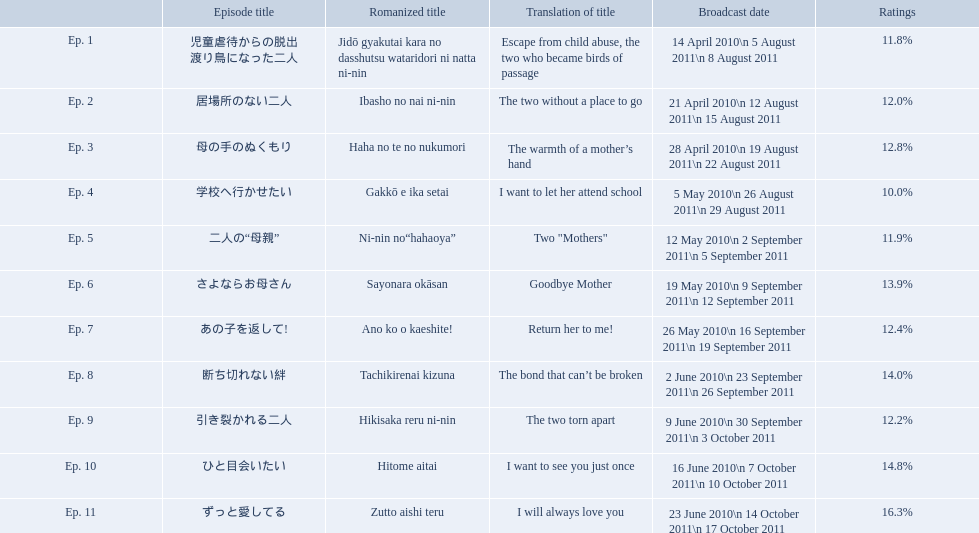Parse the table in full. {'header': ['', 'Episode title', 'Romanized title', 'Translation of title', 'Broadcast date', 'Ratings'], 'rows': [['Ep. 1', '児童虐待からの脱出 渡り鳥になった二人', 'Jidō gyakutai kara no dasshutsu wataridori ni natta ni-nin', 'Escape from child abuse, the two who became birds of passage', '14 April 2010\\n 5 August 2011\\n 8 August 2011', '11.8%'], ['Ep. 2', '居場所のない二人', 'Ibasho no nai ni-nin', 'The two without a place to go', '21 April 2010\\n 12 August 2011\\n 15 August 2011', '12.0%'], ['Ep. 3', '母の手のぬくもり', 'Haha no te no nukumori', 'The warmth of a mother’s hand', '28 April 2010\\n 19 August 2011\\n 22 August 2011', '12.8%'], ['Ep. 4', '学校へ行かせたい', 'Gakkō e ika setai', 'I want to let her attend school', '5 May 2010\\n 26 August 2011\\n 29 August 2011', '10.0%'], ['Ep. 5', '二人の“母親”', 'Ni-nin no“hahaoya”', 'Two "Mothers"', '12 May 2010\\n 2 September 2011\\n 5 September 2011', '11.9%'], ['Ep. 6', 'さよならお母さん', 'Sayonara okāsan', 'Goodbye Mother', '19 May 2010\\n 9 September 2011\\n 12 September 2011', '13.9%'], ['Ep. 7', 'あの子を返して!', 'Ano ko o kaeshite!', 'Return her to me!', '26 May 2010\\n 16 September 2011\\n 19 September 2011', '12.4%'], ['Ep. 8', '断ち切れない絆', 'Tachikirenai kizuna', 'The bond that can’t be broken', '2 June 2010\\n 23 September 2011\\n 26 September 2011', '14.0%'], ['Ep. 9', '引き裂かれる二人', 'Hikisaka reru ni-nin', 'The two torn apart', '9 June 2010\\n 30 September 2011\\n 3 October 2011', '12.2%'], ['Ep. 10', 'ひと目会いたい', 'Hitome aitai', 'I want to see you just once', '16 June 2010\\n 7 October 2011\\n 10 October 2011', '14.8%'], ['Ep. 11', 'ずっと愛してる', 'Zutto aishi teru', 'I will always love you', '23 June 2010\\n 14 October 2011\\n 17 October 2011', '16.3%']]} What are all the episodes? Ep. 1, Ep. 2, Ep. 3, Ep. 4, Ep. 5, Ep. 6, Ep. 7, Ep. 8, Ep. 9, Ep. 10, Ep. 11. Of these, which ones have a rating of 14%? Ep. 8, Ep. 10. Of these, which one is not ep. 10? Ep. 8. What are the episode numbers? Ep. 1, Ep. 2, Ep. 3, Ep. 4, Ep. 5, Ep. 6, Ep. 7, Ep. 8, Ep. 9, Ep. 10, Ep. 11. What was the percentage of total ratings for episode 8? 14.0%. Which episode was titled the two without a place to go? Ep. 2. What was the title of ep. 3? The warmth of a mother’s hand. Which episode had a rating of 10.0%? Ep. 4. What are all the titles the episodes of the mother tv series? 児童虐待からの脱出 渡り鳥になった二人, 居場所のない二人, 母の手のぬくもり, 学校へ行かせたい, 二人の“母親”, さよならお母さん, あの子を返して!, 断ち切れない絆, 引き裂かれる二人, ひと目会いたい, ずっと愛してる. What are all of the ratings for each of the shows? 11.8%, 12.0%, 12.8%, 10.0%, 11.9%, 13.9%, 12.4%, 14.0%, 12.2%, 14.8%, 16.3%. What is the highest score for ratings? 16.3%. What episode corresponds to that rating? ずっと愛してる. What is the overall number of episodes? Ep. 1, Ep. 2, Ep. 3, Ep. 4, Ep. 5, Ep. 6, Ep. 7, Ep. 8, Ep. 9, Ep. 10, Ep. 11. Among them, which one carries the title "the bond that can't be broken"? Ep. 8. What percentage of ratings did that particular episode receive? 14.0%. What is the title of episode 8? 断ち切れない絆. What were the ratings for this episode? 14.0%. What are the complete list of episode titles in the mother tv series? 児童虐待からの脱出 渡り鳥になった二人, 居場所のない二人, 母の手のぬくもり, 学校へ行かせたい, 二人の“母親”, さよならお母さん, あの子を返して!, 断ち切れない絆, 引き裂かれる二人, ひと目会いたい, ずっと愛してる. What are the respective ratings for each episode? 11.8%, 12.0%, 12.8%, 10.0%, 11.9%, 13.9%, 12.4%, 14.0%, 12.2%, 14.8%, 16.3%. What is the top rating received? 16.3%. Which episode corresponds to that score? ずっと愛してる. What are the installment numbers? Ep. 1, Ep. 2, Ep. 3, Ep. 4, Ep. 5, Ep. 6, Ep. 7, Ep. 8, Ep. 9, Ep. 10, Ep. 11. What was the proportion of total ratings for episode 8? 14.0%. What are the titles of all the episodes in the mother television series? 児童虐待からの脱出 渡り鳥になった二人, 居場所のない二人, 母の手のぬくもり, 学校へ行かせたい, 二人の“母親”, さよならお母さん, あの子を返して!, 断ち切れない絆, 引き裂かれる二人, ひと目会いたい, ずっと愛してる. What are the ratings given to each of the episodes? 11.8%, 12.0%, 12.8%, 10.0%, 11.9%, 13.9%, 12.4%, 14.0%, 12.2%, 14.8%, 16.3%. What is the peak rating achieved? 16.3%. What episode is linked to that rating? ずっと愛してる. What are the names of every episode in the mother television series? 児童虐待からの脱出 渡り鳥になった二人, 居場所のない二人, 母の手のぬくもり, 学校へ行かせたい, 二人の“母親”, さよならお母さん, あの子を返して!, 断ち切れない絆, 引き裂かれる二人, ひと目会いたい, ずっと愛してる. What are the individual ratings for each episode? 11.8%, 12.0%, 12.8%, 10.0%, 11.9%, 13.9%, 12.4%, 14.0%, 12.2%, 14.8%, 16.3%. What is the maximum rating achieved? 16.3%. Which episode is associated with that rating? ずっと愛してる. What episodes are included in the series "mother"? 児童虐待からの脱出 渡り鳥になった二人, 居場所のない二人, 母の手のぬくもり, 学校へ行かせたい, 二人の“母親”, さよならお母さん, あの子を返して!, 断ち切れない絆, 引き裂かれる二人, ひと目会いたい, ずっと愛してる. What is the rating for the 10th episode? 14.8%. Additionally, what other ratings fall within the 14-15 range? Ep. 8. Can you provide the episodes of "mother"? 児童虐待からの脱出 渡り鳥になった二人, 居場所のない二人, 母の手のぬくもり, 学校へ行かせたい, 二人の“母親”, さよならお母さん, あの子を返して!, 断ち切れない絆, 引き裂かれる二人, ひと目会いたい, ずっと愛してる. What rating does the 10th episode have? 14.8%. Also, which other ratings are in the 14-15 range? Ep. 8. What is the total number of episodes? Ep. 1, Ep. 2, Ep. 3, Ep. 4, Ep. 5, Ep. 6, Ep. 7, Ep. 8, Ep. 9, Ep. 10, Ep. 11. Among them, which episode is titled "the bond that can't be broken"? Ep. 8. What percentage of ratings did this episode receive? 14.0%. What's the overall count of episodes? Ep. 1, Ep. 2, Ep. 3, Ep. 4, Ep. 5, Ep. 6, Ep. 7, Ep. 8, Ep. 9, Ep. 10, Ep. 11. In that list, which episode bears the title "the bond that can't be broken"? Ep. 8. What was the ratings percentage for this specific episode? 14.0%. How many episodes are there in total? Ep. 1, Ep. 2, Ep. 3, Ep. 4, Ep. 5, Ep. 6, Ep. 7, Ep. 8, Ep. 9, Ep. 10, Ep. 11. Which one among them has the title "the bond that can't be broken"? Ep. 8. What was the percentage of ratings for that particular episode? 14.0%. What are all the episode names of the show "mother"? 児童虐待からの脱出 渡り鳥になった二人, 居場所のない二人, 母の手のぬくもり, 学校へ行かせたい, 二人の“母親”, さよならお母さん, あの子を返して!, 断ち切れない絆, 引き裂かれる二人, ひと目会いたい, ずっと愛してる. What are the translated titles for the episodes of "mother"? Escape from child abuse, the two who became birds of passage, The two without a place to go, The warmth of a mother’s hand, I want to let her attend school, Two "Mothers", Goodbye Mother, Return her to me!, The bond that can’t be broken, The two torn apart, I want to see you just once, I will always love you. Which episode had the translation "i want to let her attend school"? Ep. 4. What were the titles of every episode in the tv show "mother"? 児童虐待からの脱出 渡り鳥になった二人, 居場所のない二人, 母の手のぬくもり, 学校へ行かせたい, 二人の“母親”, さよならお母さん, あの子を返して!, 断ち切れない絆, 引き裂かれる二人, ひと目会いたい, ずっと愛してる. What were their translated titles? Escape from child abuse, the two who became birds of passage, The two without a place to go, The warmth of a mother’s hand, I want to let her attend school, Two "Mothers", Goodbye Mother, Return her to me!, The bond that can’t be broken, The two torn apart, I want to see you just once, I will always love you. Which particular episode had the translation "i want to let her attend school"? Ep. 4. What were the titles of the episodes in the series "mother"? 児童虐待からの脱出 渡り鳥になった二人, 居場所のない二人, 母の手のぬくもり, 学校へ行かせたい, 二人の“母親”, さよならお母さん, あの子を返して!, 断ち切れない絆, 引き裂かれる二人, ひと目会いたい, ずっと愛してる. Which episode received the highest ratings among them? ずっと愛してる. For every episode, what are their respective rating percentages? 11.8%, 12.0%, 12.8%, 10.0%, 11.9%, 13.9%, 12.4%, 14.0%, 12.2%, 14.8%, 16.3%. What is the maximum rating achieved by an episode? 16.3%. Can you parse all the data within this table? {'header': ['', 'Episode title', 'Romanized title', 'Translation of title', 'Broadcast date', 'Ratings'], 'rows': [['Ep. 1', '児童虐待からの脱出 渡り鳥になった二人', 'Jidō gyakutai kara no dasshutsu wataridori ni natta ni-nin', 'Escape from child abuse, the two who became birds of passage', '14 April 2010\\n 5 August 2011\\n 8 August 2011', '11.8%'], ['Ep. 2', '居場所のない二人', 'Ibasho no nai ni-nin', 'The two without a place to go', '21 April 2010\\n 12 August 2011\\n 15 August 2011', '12.0%'], ['Ep. 3', '母の手のぬくもり', 'Haha no te no nukumori', 'The warmth of a mother’s hand', '28 April 2010\\n 19 August 2011\\n 22 August 2011', '12.8%'], ['Ep. 4', '学校へ行かせたい', 'Gakkō e ika setai', 'I want to let her attend school', '5 May 2010\\n 26 August 2011\\n 29 August 2011', '10.0%'], ['Ep. 5', '二人の“母親”', 'Ni-nin no“hahaoya”', 'Two "Mothers"', '12 May 2010\\n 2 September 2011\\n 5 September 2011', '11.9%'], ['Ep. 6', 'さよならお母さん', 'Sayonara okāsan', 'Goodbye Mother', '19 May 2010\\n 9 September 2011\\n 12 September 2011', '13.9%'], ['Ep. 7', 'あの子を返して!', 'Ano ko o kaeshite!', 'Return her to me!', '26 May 2010\\n 16 September 2011\\n 19 September 2011', '12.4%'], ['Ep. 8', '断ち切れない絆', 'Tachikirenai kizuna', 'The bond that can’t be broken', '2 June 2010\\n 23 September 2011\\n 26 September 2011', '14.0%'], ['Ep. 9', '引き裂かれる二人', 'Hikisaka reru ni-nin', 'The two torn apart', '9 June 2010\\n 30 September 2011\\n 3 October 2011', '12.2%'], ['Ep. 10', 'ひと目会いたい', 'Hitome aitai', 'I want to see you just once', '16 June 2010\\n 7 October 2011\\n 10 October 2011', '14.8%'], ['Ep. 11', 'ずっと愛してる', 'Zutto aishi teru', 'I will always love you', '23 June 2010\\n 14 October 2011\\n 17 October 2011', '16.3%']]} Which episode had a 16.3% rating? ずっと愛してる. 